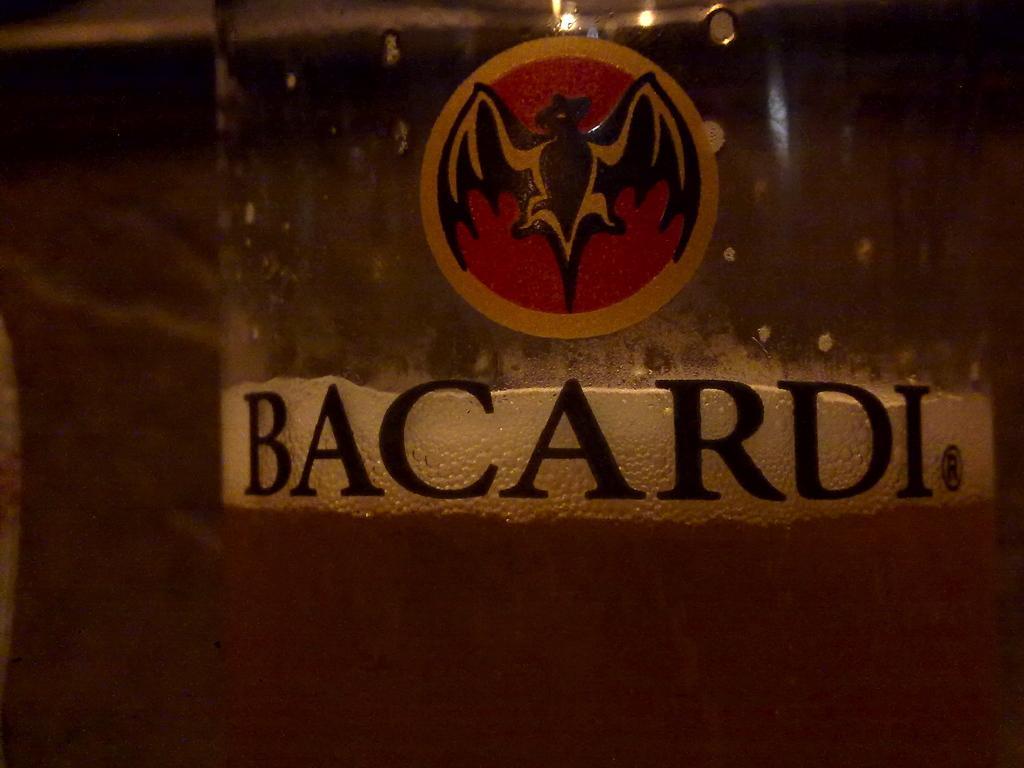Could you give a brief overview of what you see in this image? In this picture we can see a sticker, text on the glass with drink in it and in the background it is blurry. 